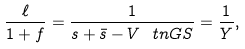<formula> <loc_0><loc_0><loc_500><loc_500>\frac { \ell } { 1 + f } = \frac { 1 } { s + \bar { s } - V ^ { \ } t n { G S } } = \frac { 1 } { Y } ,</formula> 